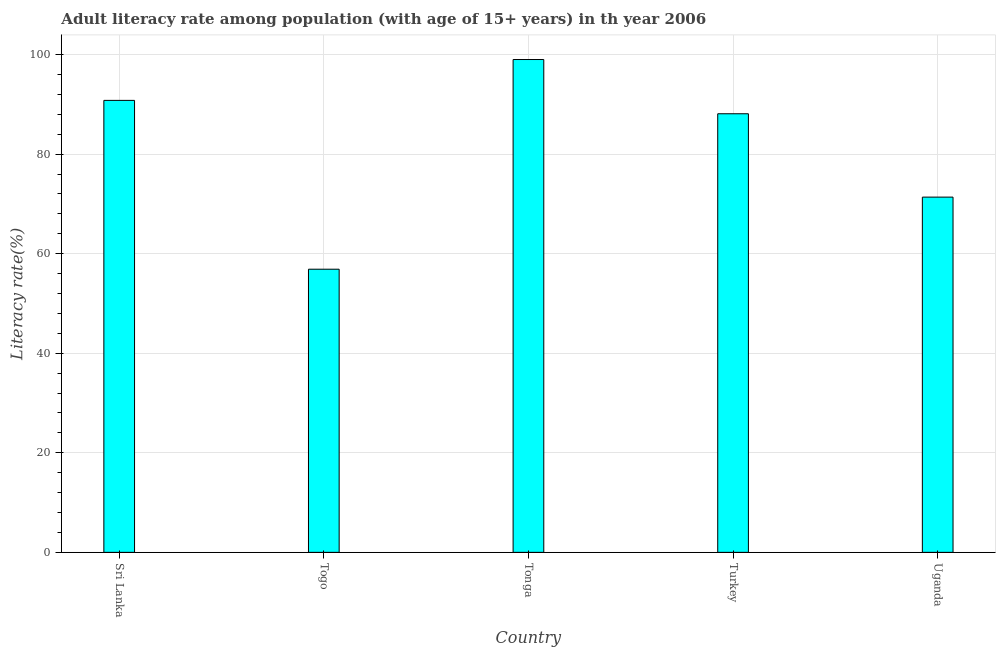Does the graph contain any zero values?
Ensure brevity in your answer.  No. Does the graph contain grids?
Give a very brief answer. Yes. What is the title of the graph?
Provide a short and direct response. Adult literacy rate among population (with age of 15+ years) in th year 2006. What is the label or title of the Y-axis?
Your answer should be very brief. Literacy rate(%). What is the adult literacy rate in Sri Lanka?
Keep it short and to the point. 90.81. Across all countries, what is the maximum adult literacy rate?
Your answer should be very brief. 99.02. Across all countries, what is the minimum adult literacy rate?
Ensure brevity in your answer.  56.89. In which country was the adult literacy rate maximum?
Your answer should be compact. Tonga. In which country was the adult literacy rate minimum?
Offer a terse response. Togo. What is the sum of the adult literacy rate?
Your answer should be compact. 406.21. What is the difference between the adult literacy rate in Turkey and Uganda?
Provide a short and direct response. 16.75. What is the average adult literacy rate per country?
Your response must be concise. 81.24. What is the median adult literacy rate?
Offer a terse response. 88.12. In how many countries, is the adult literacy rate greater than 92 %?
Offer a terse response. 1. What is the ratio of the adult literacy rate in Togo to that in Tonga?
Your response must be concise. 0.57. What is the difference between the highest and the second highest adult literacy rate?
Your response must be concise. 8.21. Is the sum of the adult literacy rate in Togo and Turkey greater than the maximum adult literacy rate across all countries?
Offer a terse response. Yes. What is the difference between the highest and the lowest adult literacy rate?
Offer a terse response. 42.13. In how many countries, is the adult literacy rate greater than the average adult literacy rate taken over all countries?
Provide a succinct answer. 3. How many bars are there?
Your answer should be very brief. 5. What is the difference between two consecutive major ticks on the Y-axis?
Make the answer very short. 20. Are the values on the major ticks of Y-axis written in scientific E-notation?
Your answer should be very brief. No. What is the Literacy rate(%) of Sri Lanka?
Your answer should be compact. 90.81. What is the Literacy rate(%) in Togo?
Ensure brevity in your answer.  56.89. What is the Literacy rate(%) of Tonga?
Give a very brief answer. 99.02. What is the Literacy rate(%) in Turkey?
Your answer should be very brief. 88.12. What is the Literacy rate(%) in Uganda?
Your answer should be very brief. 71.37. What is the difference between the Literacy rate(%) in Sri Lanka and Togo?
Offer a very short reply. 33.92. What is the difference between the Literacy rate(%) in Sri Lanka and Tonga?
Your answer should be very brief. -8.21. What is the difference between the Literacy rate(%) in Sri Lanka and Turkey?
Your answer should be compact. 2.69. What is the difference between the Literacy rate(%) in Sri Lanka and Uganda?
Ensure brevity in your answer.  19.44. What is the difference between the Literacy rate(%) in Togo and Tonga?
Your answer should be compact. -42.13. What is the difference between the Literacy rate(%) in Togo and Turkey?
Ensure brevity in your answer.  -31.23. What is the difference between the Literacy rate(%) in Togo and Uganda?
Give a very brief answer. -14.48. What is the difference between the Literacy rate(%) in Tonga and Turkey?
Your answer should be compact. 10.9. What is the difference between the Literacy rate(%) in Tonga and Uganda?
Offer a terse response. 27.65. What is the difference between the Literacy rate(%) in Turkey and Uganda?
Make the answer very short. 16.75. What is the ratio of the Literacy rate(%) in Sri Lanka to that in Togo?
Make the answer very short. 1.6. What is the ratio of the Literacy rate(%) in Sri Lanka to that in Tonga?
Your answer should be compact. 0.92. What is the ratio of the Literacy rate(%) in Sri Lanka to that in Turkey?
Your response must be concise. 1.03. What is the ratio of the Literacy rate(%) in Sri Lanka to that in Uganda?
Offer a terse response. 1.27. What is the ratio of the Literacy rate(%) in Togo to that in Tonga?
Your answer should be very brief. 0.57. What is the ratio of the Literacy rate(%) in Togo to that in Turkey?
Your answer should be compact. 0.65. What is the ratio of the Literacy rate(%) in Togo to that in Uganda?
Offer a very short reply. 0.8. What is the ratio of the Literacy rate(%) in Tonga to that in Turkey?
Keep it short and to the point. 1.12. What is the ratio of the Literacy rate(%) in Tonga to that in Uganda?
Give a very brief answer. 1.39. What is the ratio of the Literacy rate(%) in Turkey to that in Uganda?
Your answer should be very brief. 1.24. 